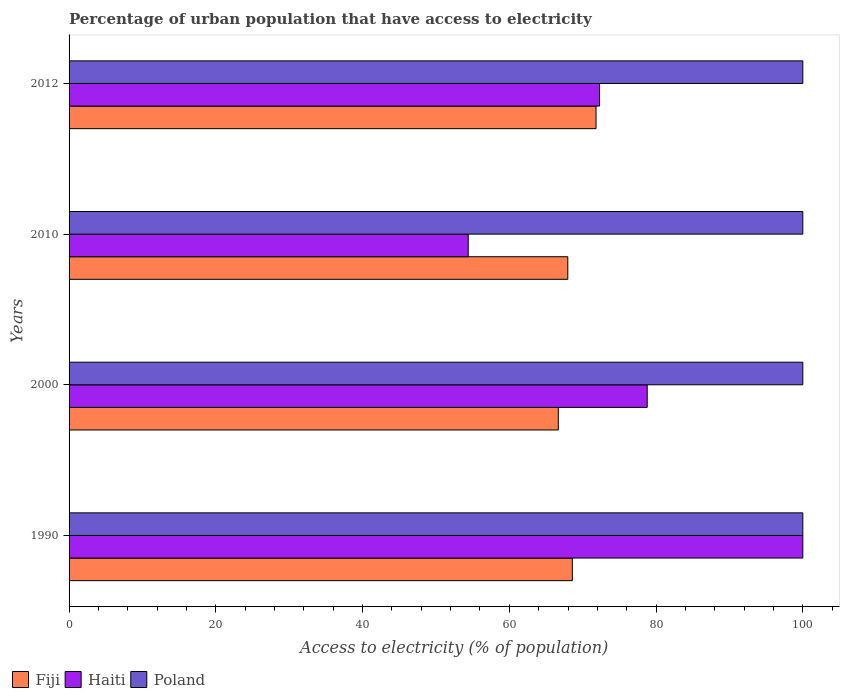How many different coloured bars are there?
Your answer should be very brief. 3. How many groups of bars are there?
Provide a succinct answer. 4. Are the number of bars per tick equal to the number of legend labels?
Your answer should be compact. Yes. How many bars are there on the 1st tick from the bottom?
Your answer should be very brief. 3. What is the label of the 4th group of bars from the top?
Your answer should be very brief. 1990. What is the percentage of urban population that have access to electricity in Fiji in 2010?
Your response must be concise. 67.97. Across all years, what is the maximum percentage of urban population that have access to electricity in Haiti?
Offer a terse response. 100. Across all years, what is the minimum percentage of urban population that have access to electricity in Fiji?
Provide a succinct answer. 66.68. In which year was the percentage of urban population that have access to electricity in Fiji minimum?
Provide a succinct answer. 2000. What is the total percentage of urban population that have access to electricity in Poland in the graph?
Your answer should be compact. 400. What is the difference between the percentage of urban population that have access to electricity in Haiti in 2000 and that in 2010?
Provide a short and direct response. 24.39. What is the difference between the percentage of urban population that have access to electricity in Haiti in 2010 and the percentage of urban population that have access to electricity in Fiji in 2000?
Provide a short and direct response. -12.28. What is the average percentage of urban population that have access to electricity in Haiti per year?
Provide a short and direct response. 76.37. In the year 2000, what is the difference between the percentage of urban population that have access to electricity in Haiti and percentage of urban population that have access to electricity in Poland?
Provide a succinct answer. -21.2. What is the ratio of the percentage of urban population that have access to electricity in Haiti in 2010 to that in 2012?
Give a very brief answer. 0.75. Is the percentage of urban population that have access to electricity in Fiji in 2000 less than that in 2010?
Your response must be concise. Yes. Is the difference between the percentage of urban population that have access to electricity in Haiti in 1990 and 2012 greater than the difference between the percentage of urban population that have access to electricity in Poland in 1990 and 2012?
Offer a very short reply. Yes. What is the difference between the highest and the lowest percentage of urban population that have access to electricity in Poland?
Offer a terse response. 0. In how many years, is the percentage of urban population that have access to electricity in Fiji greater than the average percentage of urban population that have access to electricity in Fiji taken over all years?
Make the answer very short. 1. What does the 3rd bar from the top in 2010 represents?
Offer a very short reply. Fiji. What does the 2nd bar from the bottom in 2000 represents?
Provide a succinct answer. Haiti. Is it the case that in every year, the sum of the percentage of urban population that have access to electricity in Haiti and percentage of urban population that have access to electricity in Fiji is greater than the percentage of urban population that have access to electricity in Poland?
Offer a very short reply. Yes. How many bars are there?
Provide a short and direct response. 12. Are the values on the major ticks of X-axis written in scientific E-notation?
Give a very brief answer. No. How many legend labels are there?
Provide a succinct answer. 3. What is the title of the graph?
Offer a very short reply. Percentage of urban population that have access to electricity. Does "Iraq" appear as one of the legend labels in the graph?
Your response must be concise. No. What is the label or title of the X-axis?
Make the answer very short. Access to electricity (% of population). What is the label or title of the Y-axis?
Keep it short and to the point. Years. What is the Access to electricity (% of population) in Fiji in 1990?
Offer a very short reply. 68.59. What is the Access to electricity (% of population) of Poland in 1990?
Your answer should be compact. 100. What is the Access to electricity (% of population) of Fiji in 2000?
Offer a very short reply. 66.68. What is the Access to electricity (% of population) in Haiti in 2000?
Keep it short and to the point. 78.8. What is the Access to electricity (% of population) of Poland in 2000?
Your response must be concise. 100. What is the Access to electricity (% of population) in Fiji in 2010?
Your answer should be very brief. 67.97. What is the Access to electricity (% of population) of Haiti in 2010?
Offer a very short reply. 54.4. What is the Access to electricity (% of population) of Poland in 2010?
Provide a succinct answer. 100. What is the Access to electricity (% of population) of Fiji in 2012?
Provide a short and direct response. 71.82. What is the Access to electricity (% of population) in Haiti in 2012?
Make the answer very short. 72.3. What is the Access to electricity (% of population) of Poland in 2012?
Ensure brevity in your answer.  100. Across all years, what is the maximum Access to electricity (% of population) of Fiji?
Ensure brevity in your answer.  71.82. Across all years, what is the maximum Access to electricity (% of population) in Haiti?
Your answer should be very brief. 100. Across all years, what is the minimum Access to electricity (% of population) in Fiji?
Offer a very short reply. 66.68. Across all years, what is the minimum Access to electricity (% of population) in Haiti?
Your answer should be compact. 54.4. Across all years, what is the minimum Access to electricity (% of population) in Poland?
Provide a short and direct response. 100. What is the total Access to electricity (% of population) in Fiji in the graph?
Ensure brevity in your answer.  275.05. What is the total Access to electricity (% of population) of Haiti in the graph?
Give a very brief answer. 305.5. What is the difference between the Access to electricity (% of population) of Fiji in 1990 and that in 2000?
Offer a terse response. 1.91. What is the difference between the Access to electricity (% of population) of Haiti in 1990 and that in 2000?
Your answer should be compact. 21.2. What is the difference between the Access to electricity (% of population) of Fiji in 1990 and that in 2010?
Keep it short and to the point. 0.62. What is the difference between the Access to electricity (% of population) of Haiti in 1990 and that in 2010?
Your response must be concise. 45.6. What is the difference between the Access to electricity (% of population) in Poland in 1990 and that in 2010?
Offer a terse response. 0. What is the difference between the Access to electricity (% of population) in Fiji in 1990 and that in 2012?
Keep it short and to the point. -3.23. What is the difference between the Access to electricity (% of population) in Haiti in 1990 and that in 2012?
Offer a very short reply. 27.7. What is the difference between the Access to electricity (% of population) in Fiji in 2000 and that in 2010?
Give a very brief answer. -1.3. What is the difference between the Access to electricity (% of population) of Haiti in 2000 and that in 2010?
Provide a succinct answer. 24.39. What is the difference between the Access to electricity (% of population) in Poland in 2000 and that in 2010?
Offer a terse response. 0. What is the difference between the Access to electricity (% of population) of Fiji in 2000 and that in 2012?
Provide a short and direct response. -5.14. What is the difference between the Access to electricity (% of population) in Haiti in 2000 and that in 2012?
Your answer should be very brief. 6.5. What is the difference between the Access to electricity (% of population) of Poland in 2000 and that in 2012?
Your response must be concise. 0. What is the difference between the Access to electricity (% of population) in Fiji in 2010 and that in 2012?
Your response must be concise. -3.85. What is the difference between the Access to electricity (% of population) of Haiti in 2010 and that in 2012?
Make the answer very short. -17.9. What is the difference between the Access to electricity (% of population) of Fiji in 1990 and the Access to electricity (% of population) of Haiti in 2000?
Your response must be concise. -10.21. What is the difference between the Access to electricity (% of population) in Fiji in 1990 and the Access to electricity (% of population) in Poland in 2000?
Make the answer very short. -31.41. What is the difference between the Access to electricity (% of population) of Haiti in 1990 and the Access to electricity (% of population) of Poland in 2000?
Make the answer very short. 0. What is the difference between the Access to electricity (% of population) in Fiji in 1990 and the Access to electricity (% of population) in Haiti in 2010?
Offer a very short reply. 14.19. What is the difference between the Access to electricity (% of population) in Fiji in 1990 and the Access to electricity (% of population) in Poland in 2010?
Provide a succinct answer. -31.41. What is the difference between the Access to electricity (% of population) in Fiji in 1990 and the Access to electricity (% of population) in Haiti in 2012?
Give a very brief answer. -3.71. What is the difference between the Access to electricity (% of population) in Fiji in 1990 and the Access to electricity (% of population) in Poland in 2012?
Provide a short and direct response. -31.41. What is the difference between the Access to electricity (% of population) of Fiji in 2000 and the Access to electricity (% of population) of Haiti in 2010?
Offer a terse response. 12.28. What is the difference between the Access to electricity (% of population) in Fiji in 2000 and the Access to electricity (% of population) in Poland in 2010?
Offer a very short reply. -33.32. What is the difference between the Access to electricity (% of population) of Haiti in 2000 and the Access to electricity (% of population) of Poland in 2010?
Your response must be concise. -21.2. What is the difference between the Access to electricity (% of population) of Fiji in 2000 and the Access to electricity (% of population) of Haiti in 2012?
Offer a terse response. -5.62. What is the difference between the Access to electricity (% of population) of Fiji in 2000 and the Access to electricity (% of population) of Poland in 2012?
Keep it short and to the point. -33.32. What is the difference between the Access to electricity (% of population) of Haiti in 2000 and the Access to electricity (% of population) of Poland in 2012?
Offer a terse response. -21.2. What is the difference between the Access to electricity (% of population) of Fiji in 2010 and the Access to electricity (% of population) of Haiti in 2012?
Give a very brief answer. -4.33. What is the difference between the Access to electricity (% of population) of Fiji in 2010 and the Access to electricity (% of population) of Poland in 2012?
Make the answer very short. -32.03. What is the difference between the Access to electricity (% of population) of Haiti in 2010 and the Access to electricity (% of population) of Poland in 2012?
Your answer should be very brief. -45.6. What is the average Access to electricity (% of population) of Fiji per year?
Your response must be concise. 68.76. What is the average Access to electricity (% of population) in Haiti per year?
Your answer should be very brief. 76.37. What is the average Access to electricity (% of population) in Poland per year?
Offer a very short reply. 100. In the year 1990, what is the difference between the Access to electricity (% of population) in Fiji and Access to electricity (% of population) in Haiti?
Give a very brief answer. -31.41. In the year 1990, what is the difference between the Access to electricity (% of population) of Fiji and Access to electricity (% of population) of Poland?
Offer a very short reply. -31.41. In the year 1990, what is the difference between the Access to electricity (% of population) of Haiti and Access to electricity (% of population) of Poland?
Make the answer very short. 0. In the year 2000, what is the difference between the Access to electricity (% of population) of Fiji and Access to electricity (% of population) of Haiti?
Ensure brevity in your answer.  -12.12. In the year 2000, what is the difference between the Access to electricity (% of population) in Fiji and Access to electricity (% of population) in Poland?
Provide a short and direct response. -33.32. In the year 2000, what is the difference between the Access to electricity (% of population) in Haiti and Access to electricity (% of population) in Poland?
Your answer should be very brief. -21.2. In the year 2010, what is the difference between the Access to electricity (% of population) in Fiji and Access to electricity (% of population) in Haiti?
Keep it short and to the point. 13.57. In the year 2010, what is the difference between the Access to electricity (% of population) of Fiji and Access to electricity (% of population) of Poland?
Your answer should be very brief. -32.03. In the year 2010, what is the difference between the Access to electricity (% of population) of Haiti and Access to electricity (% of population) of Poland?
Offer a terse response. -45.6. In the year 2012, what is the difference between the Access to electricity (% of population) in Fiji and Access to electricity (% of population) in Haiti?
Provide a short and direct response. -0.48. In the year 2012, what is the difference between the Access to electricity (% of population) of Fiji and Access to electricity (% of population) of Poland?
Ensure brevity in your answer.  -28.18. In the year 2012, what is the difference between the Access to electricity (% of population) in Haiti and Access to electricity (% of population) in Poland?
Make the answer very short. -27.7. What is the ratio of the Access to electricity (% of population) in Fiji in 1990 to that in 2000?
Keep it short and to the point. 1.03. What is the ratio of the Access to electricity (% of population) of Haiti in 1990 to that in 2000?
Provide a short and direct response. 1.27. What is the ratio of the Access to electricity (% of population) in Poland in 1990 to that in 2000?
Ensure brevity in your answer.  1. What is the ratio of the Access to electricity (% of population) in Fiji in 1990 to that in 2010?
Your answer should be compact. 1.01. What is the ratio of the Access to electricity (% of population) of Haiti in 1990 to that in 2010?
Provide a short and direct response. 1.84. What is the ratio of the Access to electricity (% of population) of Fiji in 1990 to that in 2012?
Your response must be concise. 0.95. What is the ratio of the Access to electricity (% of population) in Haiti in 1990 to that in 2012?
Provide a succinct answer. 1.38. What is the ratio of the Access to electricity (% of population) of Fiji in 2000 to that in 2010?
Make the answer very short. 0.98. What is the ratio of the Access to electricity (% of population) in Haiti in 2000 to that in 2010?
Your response must be concise. 1.45. What is the ratio of the Access to electricity (% of population) of Fiji in 2000 to that in 2012?
Your answer should be very brief. 0.93. What is the ratio of the Access to electricity (% of population) in Haiti in 2000 to that in 2012?
Offer a very short reply. 1.09. What is the ratio of the Access to electricity (% of population) of Fiji in 2010 to that in 2012?
Your answer should be compact. 0.95. What is the ratio of the Access to electricity (% of population) in Haiti in 2010 to that in 2012?
Provide a short and direct response. 0.75. What is the ratio of the Access to electricity (% of population) in Poland in 2010 to that in 2012?
Your answer should be very brief. 1. What is the difference between the highest and the second highest Access to electricity (% of population) of Fiji?
Offer a very short reply. 3.23. What is the difference between the highest and the second highest Access to electricity (% of population) in Haiti?
Your response must be concise. 21.2. What is the difference between the highest and the lowest Access to electricity (% of population) of Fiji?
Your response must be concise. 5.14. What is the difference between the highest and the lowest Access to electricity (% of population) in Haiti?
Offer a very short reply. 45.6. What is the difference between the highest and the lowest Access to electricity (% of population) of Poland?
Offer a very short reply. 0. 